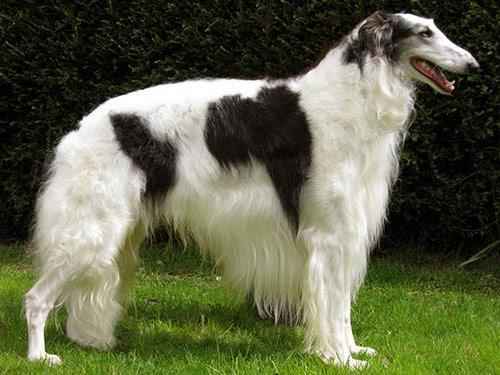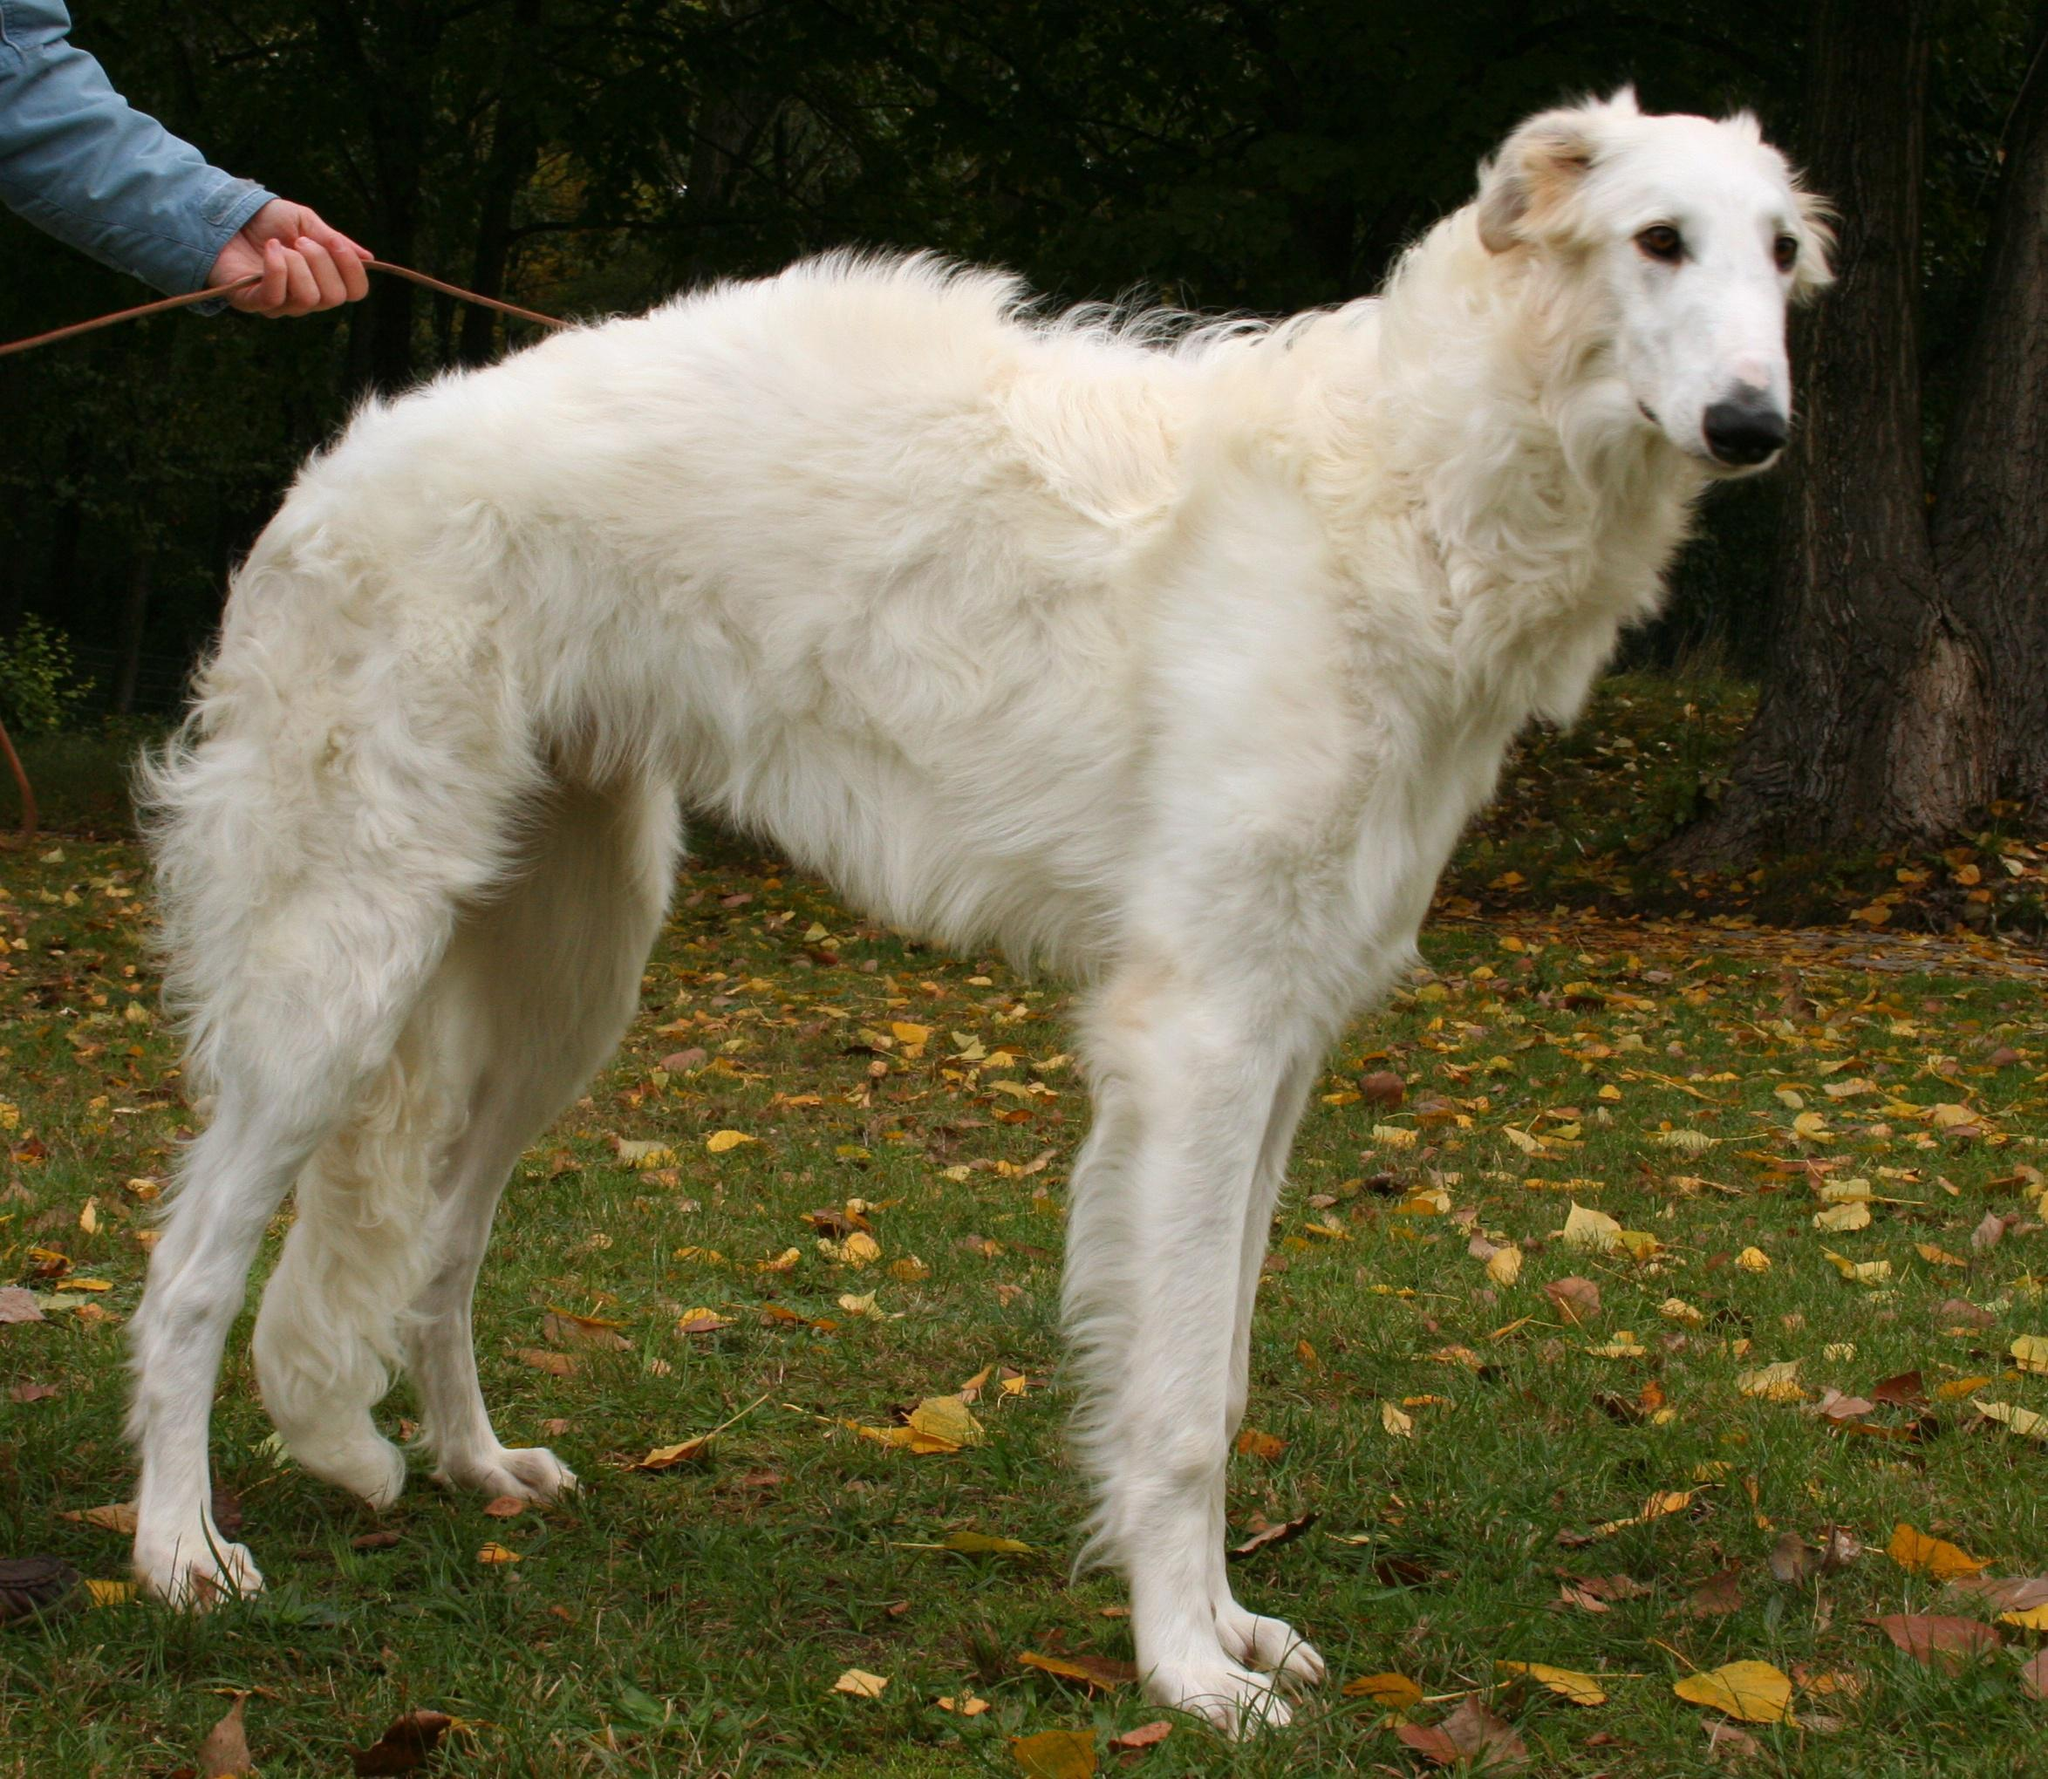The first image is the image on the left, the second image is the image on the right. Examine the images to the left and right. Is the description "Every dog has its mouth open." accurate? Answer yes or no. No. The first image is the image on the left, the second image is the image on the right. For the images shown, is this caption "There are at most 2 dogs." true? Answer yes or no. Yes. 